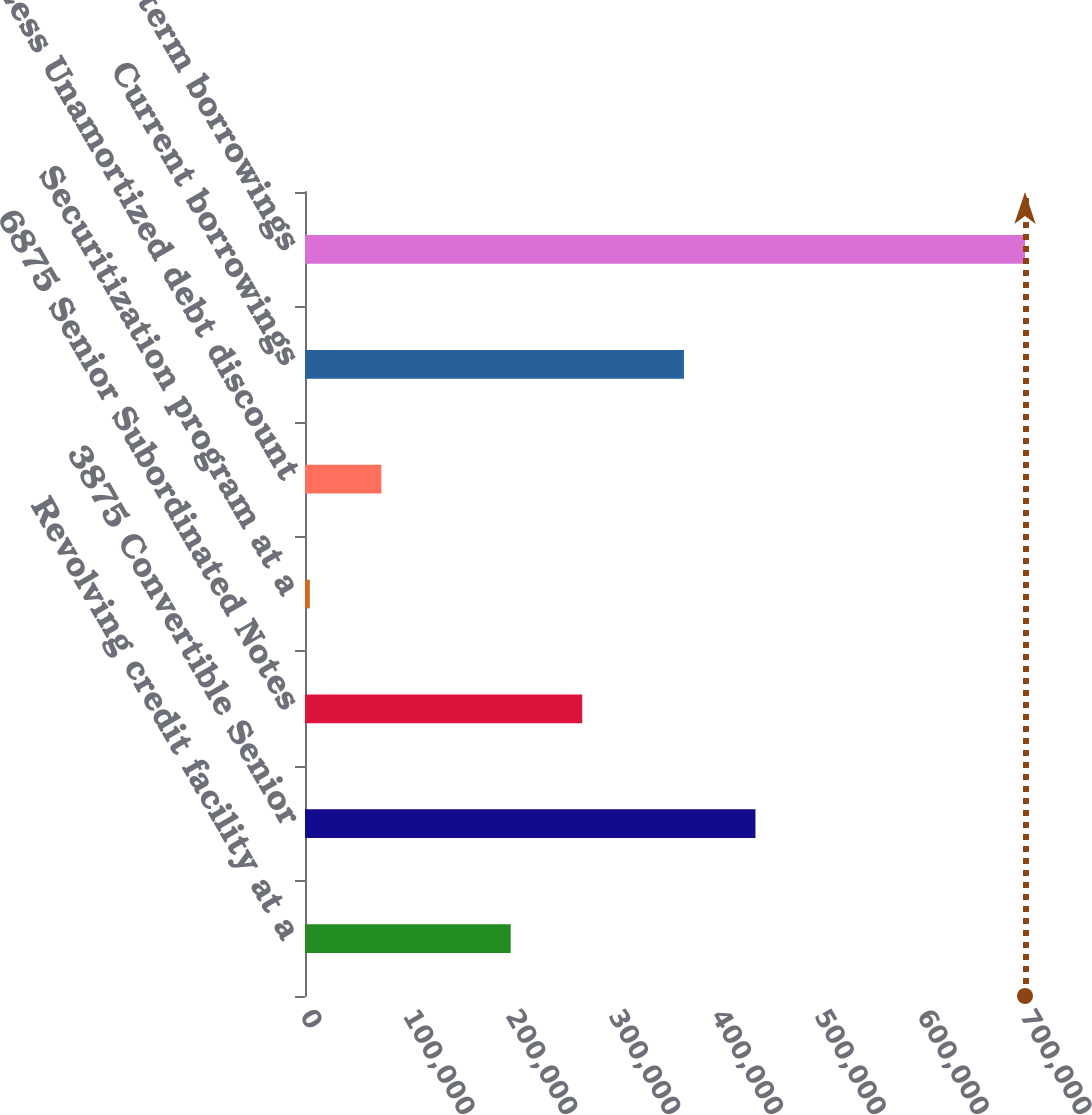Convert chart. <chart><loc_0><loc_0><loc_500><loc_500><bar_chart><fcel>Revolving credit facility at a<fcel>3875 Convertible Senior<fcel>6875 Senior Subordinated Notes<fcel>Securitization program at a<fcel>Less Unamortized debt discount<fcel>Current borrowings<fcel>Long-term borrowings<nl><fcel>200000<fcel>437931<fcel>269530<fcel>4700<fcel>74230<fcel>368401<fcel>700000<nl></chart> 